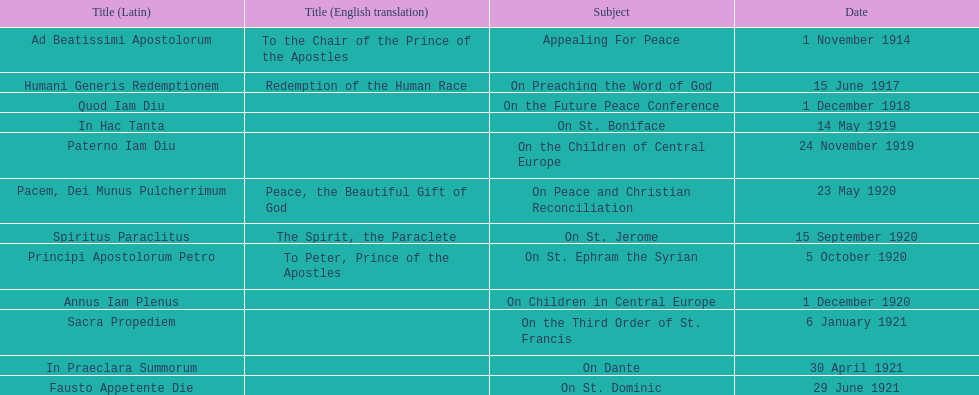How many titles have a date in november? 2. 